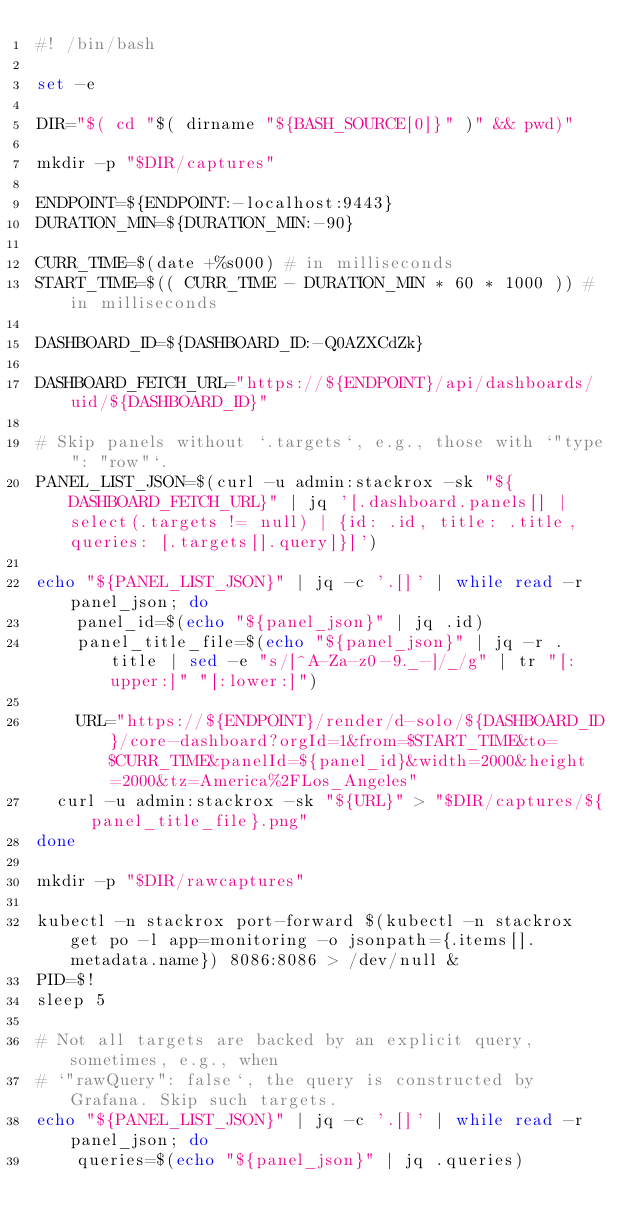Convert code to text. <code><loc_0><loc_0><loc_500><loc_500><_Bash_>#! /bin/bash

set -e

DIR="$( cd "$( dirname "${BASH_SOURCE[0]}" )" && pwd)"

mkdir -p "$DIR/captures"

ENDPOINT=${ENDPOINT:-localhost:9443}
DURATION_MIN=${DURATION_MIN:-90}

CURR_TIME=$(date +%s000) # in milliseconds
START_TIME=$(( CURR_TIME - DURATION_MIN * 60 * 1000 )) # in milliseconds

DASHBOARD_ID=${DASHBOARD_ID:-Q0AZXCdZk}

DASHBOARD_FETCH_URL="https://${ENDPOINT}/api/dashboards/uid/${DASHBOARD_ID}"

# Skip panels without `.targets`, e.g., those with `"type": "row"`.
PANEL_LIST_JSON=$(curl -u admin:stackrox -sk "${DASHBOARD_FETCH_URL}" | jq '[.dashboard.panels[] | select(.targets != null) | {id: .id, title: .title, queries: [.targets[].query]}]')

echo "${PANEL_LIST_JSON}" | jq -c '.[]' | while read -r panel_json; do
    panel_id=$(echo "${panel_json}" | jq .id)
    panel_title_file=$(echo "${panel_json}" | jq -r .title | sed -e "s/[^A-Za-z0-9._-]/_/g" | tr "[:upper:]" "[:lower:]")

    URL="https://${ENDPOINT}/render/d-solo/${DASHBOARD_ID}/core-dashboard?orgId=1&from=$START_TIME&to=$CURR_TIME&panelId=${panel_id}&width=2000&height=2000&tz=America%2FLos_Angeles"
	curl -u admin:stackrox -sk "${URL}" > "$DIR/captures/${panel_title_file}.png"
done

mkdir -p "$DIR/rawcaptures"

kubectl -n stackrox port-forward $(kubectl -n stackrox get po -l app=monitoring -o jsonpath={.items[].metadata.name}) 8086:8086 > /dev/null &
PID=$!
sleep 5

# Not all targets are backed by an explicit query, sometimes, e.g., when
# `"rawQuery": false`, the query is constructed by Grafana. Skip such targets.
echo "${PANEL_LIST_JSON}" | jq -c '.[]' | while read -r panel_json; do
    queries=$(echo "${panel_json}" | jq .queries)</code> 